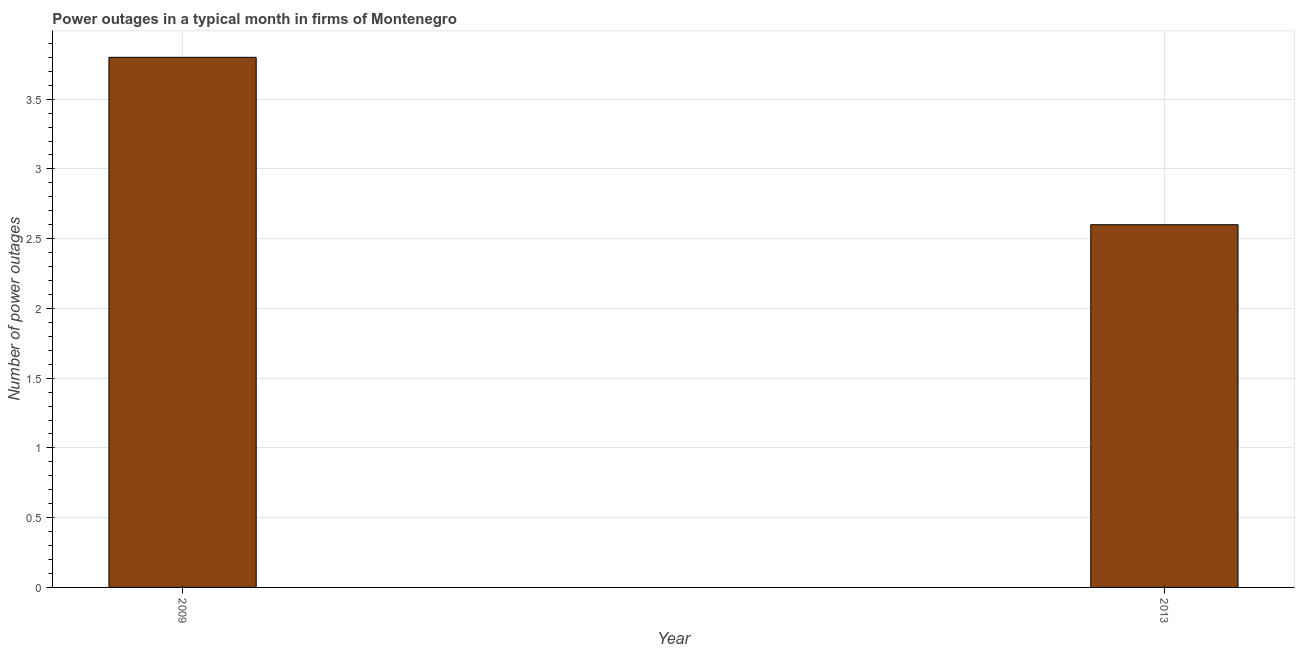Does the graph contain any zero values?
Your response must be concise. No. Does the graph contain grids?
Keep it short and to the point. Yes. What is the title of the graph?
Give a very brief answer. Power outages in a typical month in firms of Montenegro. What is the label or title of the X-axis?
Provide a succinct answer. Year. What is the label or title of the Y-axis?
Provide a short and direct response. Number of power outages. Across all years, what is the maximum number of power outages?
Your answer should be very brief. 3.8. What is the sum of the number of power outages?
Offer a terse response. 6.4. What is the median number of power outages?
Provide a short and direct response. 3.2. Do a majority of the years between 2009 and 2013 (inclusive) have number of power outages greater than 0.2 ?
Your answer should be compact. Yes. What is the ratio of the number of power outages in 2009 to that in 2013?
Your response must be concise. 1.46. Is the number of power outages in 2009 less than that in 2013?
Make the answer very short. No. How many bars are there?
Keep it short and to the point. 2. Are all the bars in the graph horizontal?
Ensure brevity in your answer.  No. What is the difference between two consecutive major ticks on the Y-axis?
Provide a short and direct response. 0.5. Are the values on the major ticks of Y-axis written in scientific E-notation?
Provide a succinct answer. No. What is the difference between the Number of power outages in 2009 and 2013?
Your answer should be compact. 1.2. What is the ratio of the Number of power outages in 2009 to that in 2013?
Your answer should be very brief. 1.46. 